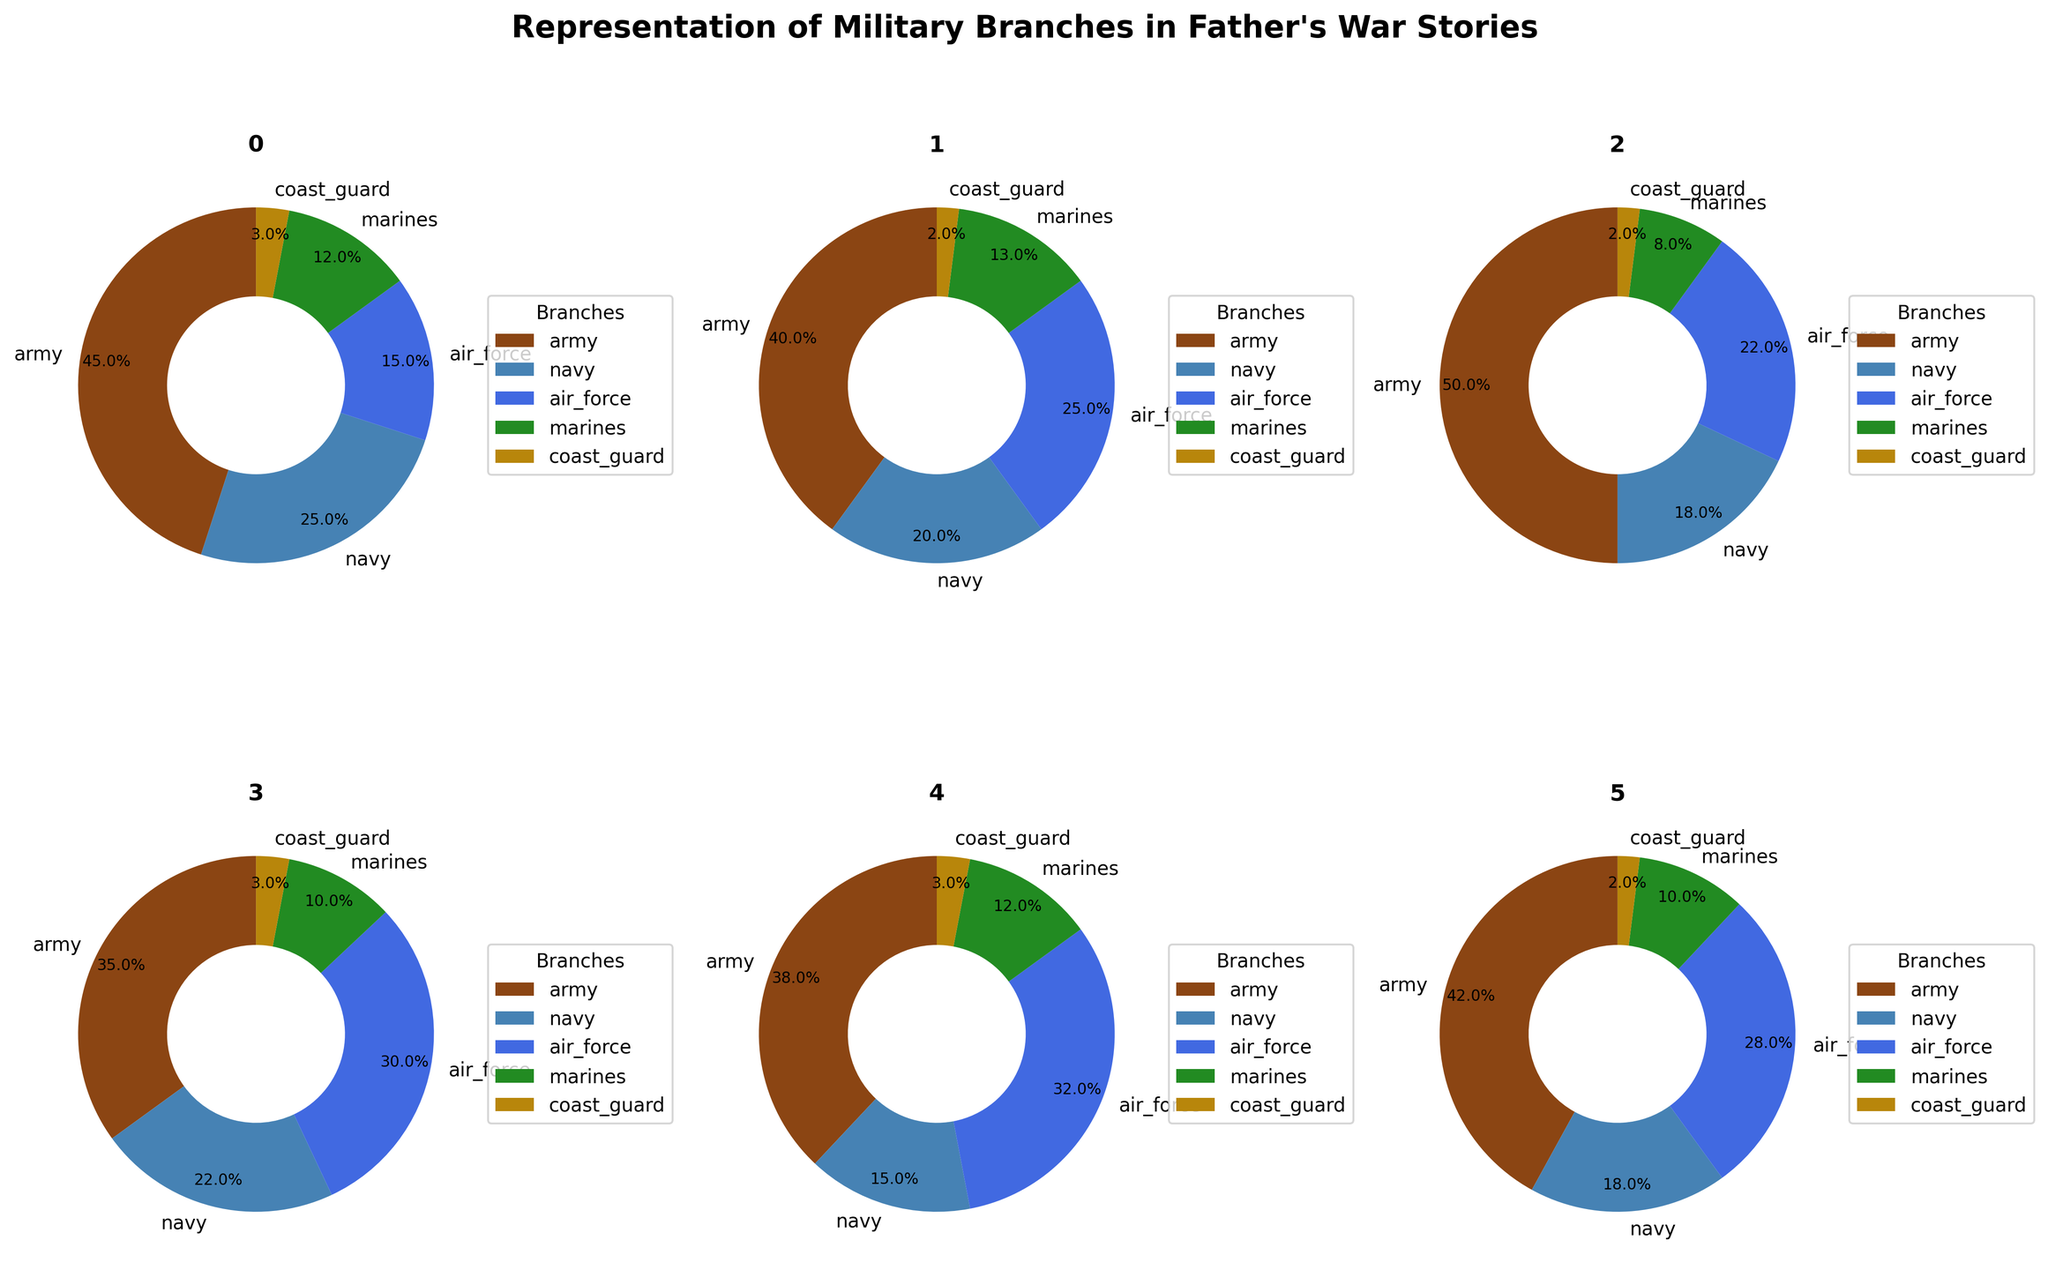Which war story includes the highest representation of the Air Force? By examining the size of the Air Force segment in each pie chart, we see that the Gulf War has the largest Air Force representation at 30%.
Answer: Gulf War Which military branch has the smallest representation across all wars? By looking at each pie chart, we notice that the Coast Guard consistently has the smallest slice in all the war stories, with percentages no greater than 3%.
Answer: Coast Guard In which war did the Army have the largest share? Comparing the Army segment percentages across all wars, the Korean War has the highest Army share with 50%.
Answer: Korean War What's the total percentage representation of the Navy in the Vietnam War and the Iraq War combined? Refer to the pie charts for the Vietnam War and Iraq War. Navy in Vietnam War is 20% and in Iraq War is 18%. Sum these percentages: 20% + 18% = 38%.
Answer: 38% How does the Marine Corps representation in World War II compare to the Marine Corps representation in the Gulf War? The pie charts indicate the Marine Corps is 12% in World War II and 10% in the Gulf War. Comparatively, it is 2% higher in World War II.
Answer: World War II has 2% more Which branch has the most consistent representation across all wars? Look at the slices for each branch across all pie charts. The Coast Guard has the most consistent representation, always hovering around 2-3%.
Answer: Coast Guard Combining the representation of the Army and Air Force, which war had the highest combined percentage? Calculate the Army and Air Force combined percentages for each war: World War II (45% + 15%), Vietnam War (40% + 25%), Korean War (50% + 22%), Gulf War (35% + 30%), Afghanistan War (38% + 32%), Iraq War (42% + 28%). The highest is the Afghanistan War with a combined total of 70%.
Answer: Afghanistan War Which military branch sees a notable increase in representation from World War II to the Gulf War? Comparing the different war stories, the Air Force shows a notable increase, going from 15% in World War II to 30% in the Gulf War.
Answer: Air Force 